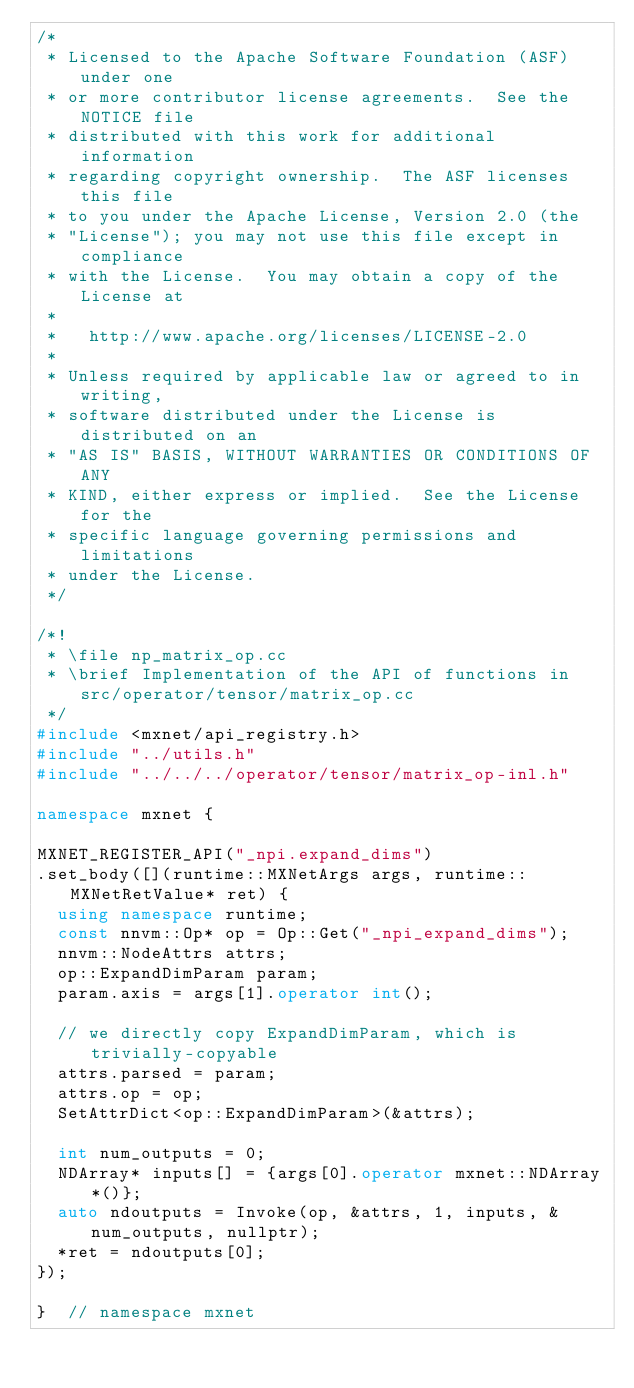<code> <loc_0><loc_0><loc_500><loc_500><_C++_>/*
 * Licensed to the Apache Software Foundation (ASF) under one
 * or more contributor license agreements.  See the NOTICE file
 * distributed with this work for additional information
 * regarding copyright ownership.  The ASF licenses this file
 * to you under the Apache License, Version 2.0 (the
 * "License"); you may not use this file except in compliance
 * with the License.  You may obtain a copy of the License at
 * 
 *   http://www.apache.org/licenses/LICENSE-2.0
 * 
 * Unless required by applicable law or agreed to in writing,
 * software distributed under the License is distributed on an
 * "AS IS" BASIS, WITHOUT WARRANTIES OR CONDITIONS OF ANY
 * KIND, either express or implied.  See the License for the
 * specific language governing permissions and limitations
 * under the License.
 */

/*!
 * \file np_matrix_op.cc
 * \brief Implementation of the API of functions in src/operator/tensor/matrix_op.cc
 */
#include <mxnet/api_registry.h>
#include "../utils.h"
#include "../../../operator/tensor/matrix_op-inl.h"

namespace mxnet {

MXNET_REGISTER_API("_npi.expand_dims")
.set_body([](runtime::MXNetArgs args, runtime::MXNetRetValue* ret) {
  using namespace runtime;
  const nnvm::Op* op = Op::Get("_npi_expand_dims");
  nnvm::NodeAttrs attrs;
  op::ExpandDimParam param;
  param.axis = args[1].operator int();

  // we directly copy ExpandDimParam, which is trivially-copyable
  attrs.parsed = param;
  attrs.op = op;
  SetAttrDict<op::ExpandDimParam>(&attrs);

  int num_outputs = 0;
  NDArray* inputs[] = {args[0].operator mxnet::NDArray*()};
  auto ndoutputs = Invoke(op, &attrs, 1, inputs, &num_outputs, nullptr);
  *ret = ndoutputs[0];
});

}  // namespace mxnet
</code> 